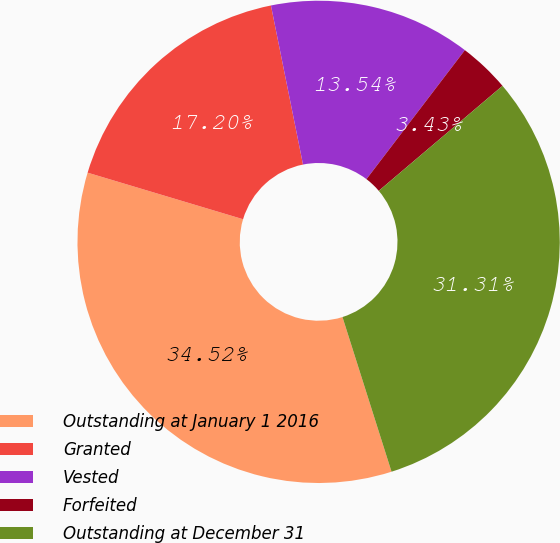<chart> <loc_0><loc_0><loc_500><loc_500><pie_chart><fcel>Outstanding at January 1 2016<fcel>Granted<fcel>Vested<fcel>Forfeited<fcel>Outstanding at December 31<nl><fcel>34.52%<fcel>17.2%<fcel>13.54%<fcel>3.43%<fcel>31.31%<nl></chart> 